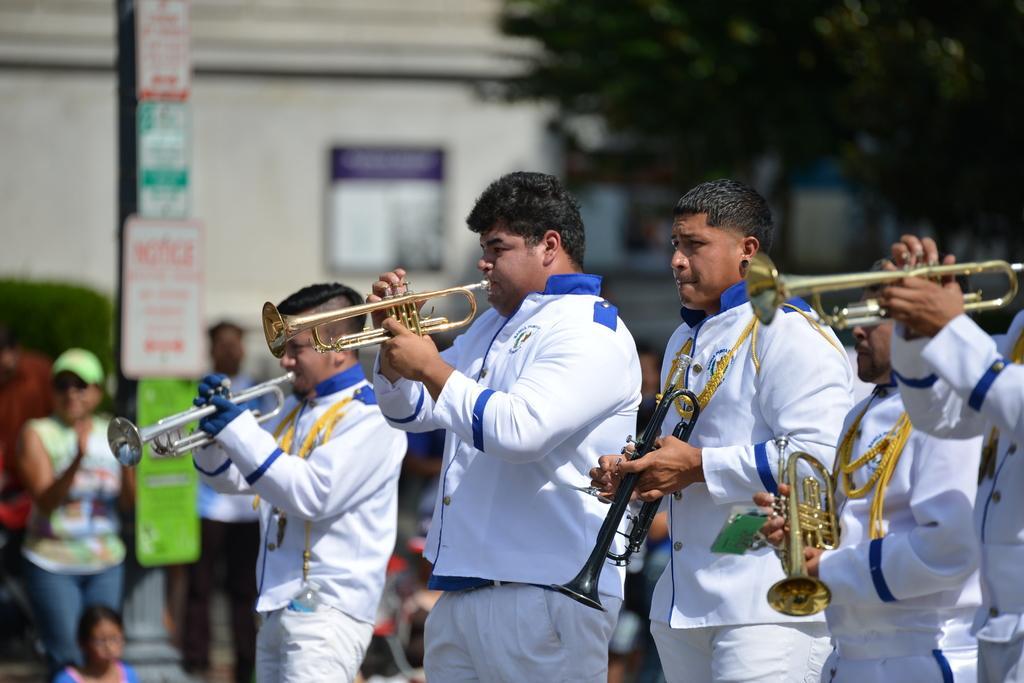Please provide a concise description of this image. In this picture I can see there are a few people standing on the right side, they are playing trumpets and there are a few people standing on the walkway and there is a tree in the backdrop and there is a pole with boards. There is a building in the backdrop. 